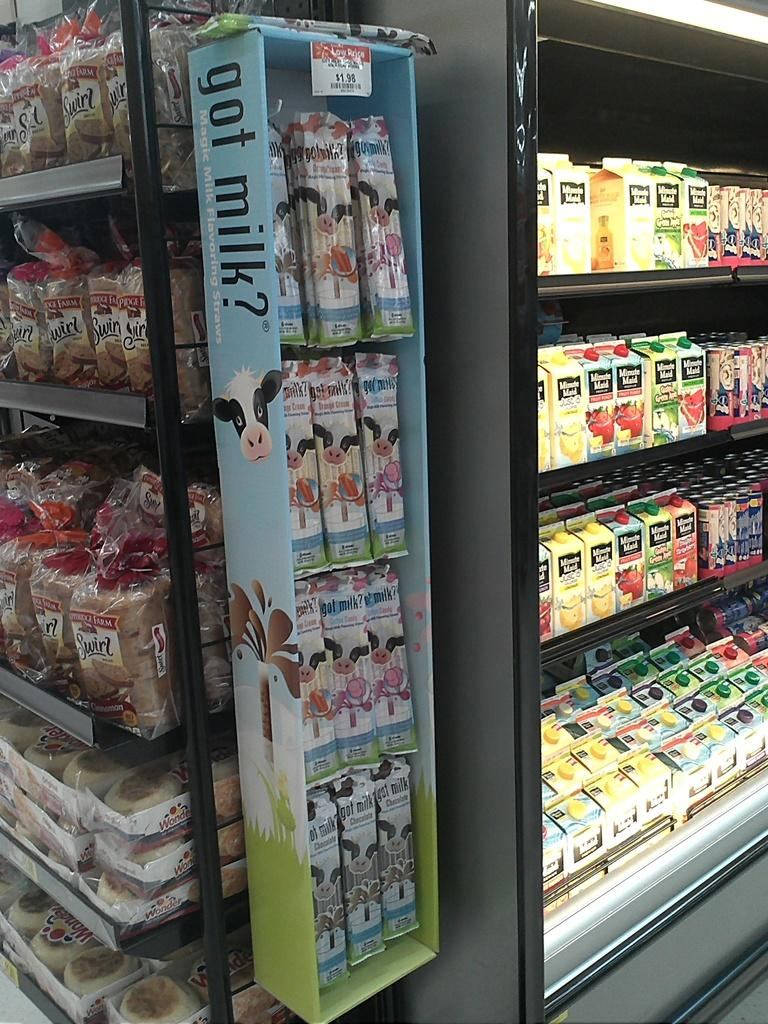<image>
Render a clear and concise summary of the photo. A box outside the cooler says got milk? on the side. 